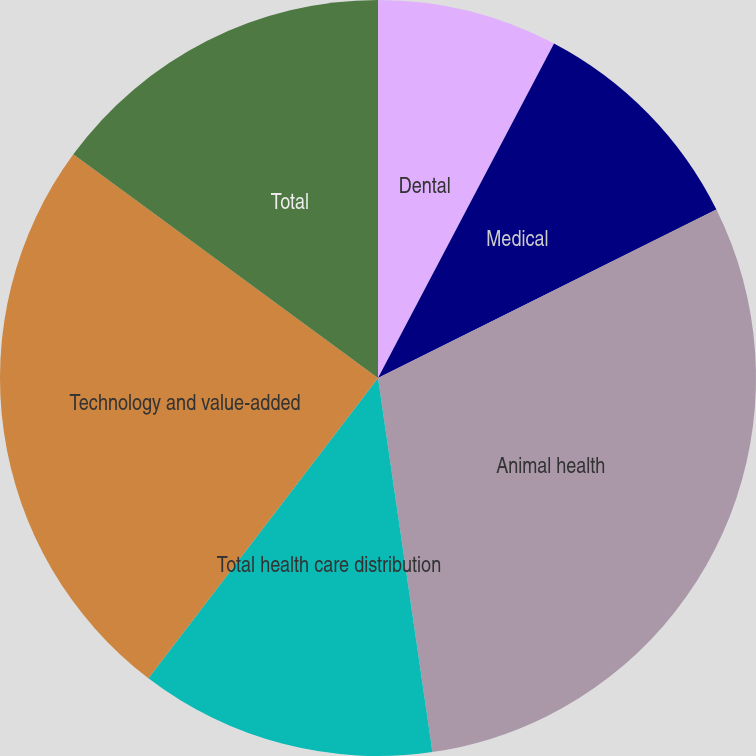Convert chart to OTSL. <chart><loc_0><loc_0><loc_500><loc_500><pie_chart><fcel>Dental<fcel>Medical<fcel>Animal health<fcel>Total health care distribution<fcel>Technology and value-added<fcel>Total<nl><fcel>7.71%<fcel>9.94%<fcel>30.05%<fcel>12.69%<fcel>24.69%<fcel>14.92%<nl></chart> 